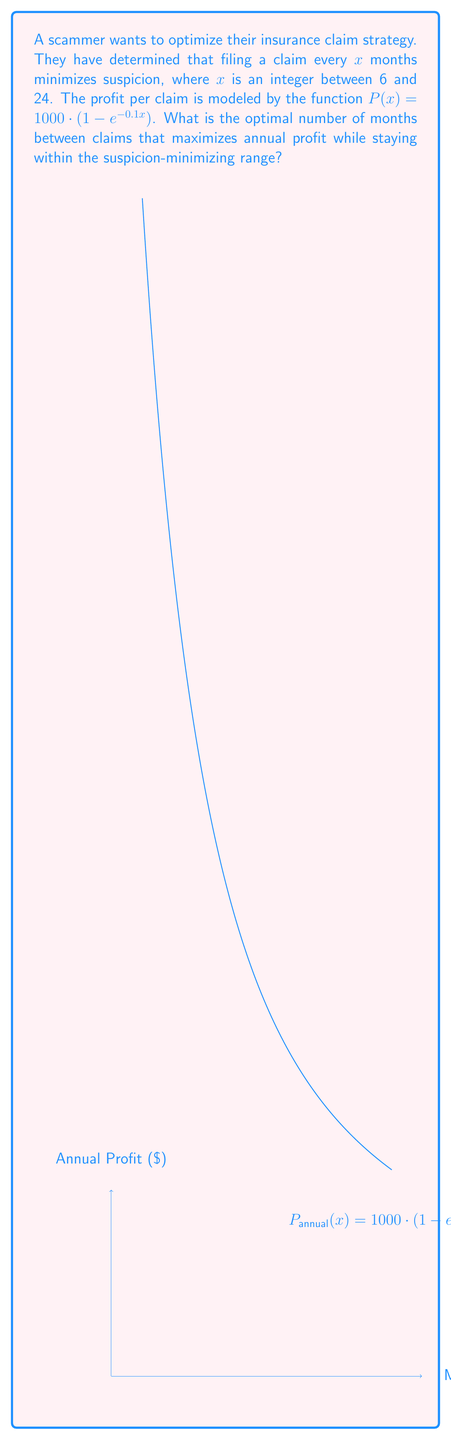Show me your answer to this math problem. To solve this problem, we need to follow these steps:

1) First, we need to express the annual profit function. Since $P(x)$ is the profit per claim, and claims are made every $x$ months, the number of claims per year is $\frac{12}{x}$. Therefore, the annual profit function is:

   $$P_{annual}(x) = P(x) \cdot \frac{12}{x} = 1000 \cdot (1 - e^{-0.1x}) \cdot \frac{12}{x}$$

2) To find the maximum of this function within the given range, we need to find the derivative and set it to zero:

   $$\frac{d}{dx}P_{annual}(x) = 1000 \cdot \left(\frac{1.2e^{-0.1x}}{x} - \frac{12(1-e^{-0.1x})}{x^2}\right)$$

3) Setting this equal to zero and simplifying:

   $$\frac{1.2e^{-0.1x}}{x} - \frac{12(1-e^{-0.1x})}{x^2} = 0$$
   $$1.2e^{-0.1x}x = 12(1-e^{-0.1x})$$
   $$0.1x = 10 - 10e^{-0.1x}$$

4) This equation cannot be solved algebraically. However, we can solve it numerically or graphically. Using a numerical method, we find that the solution is approximately $x \approx 11.5$.

5) Since we're restricted to integer values of $x$ between 6 and 24, we need to check the values of $P_{annual}(11)$ and $P_{annual}(12)$:

   $P_{annual}(11) \approx 4168.18$
   $P_{annual}(12) \approx 4174.42$

6) Therefore, the optimal integer value of $x$ within the given range is 12.
Answer: 12 months 